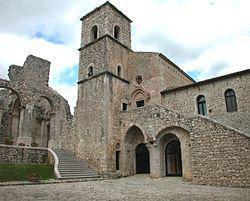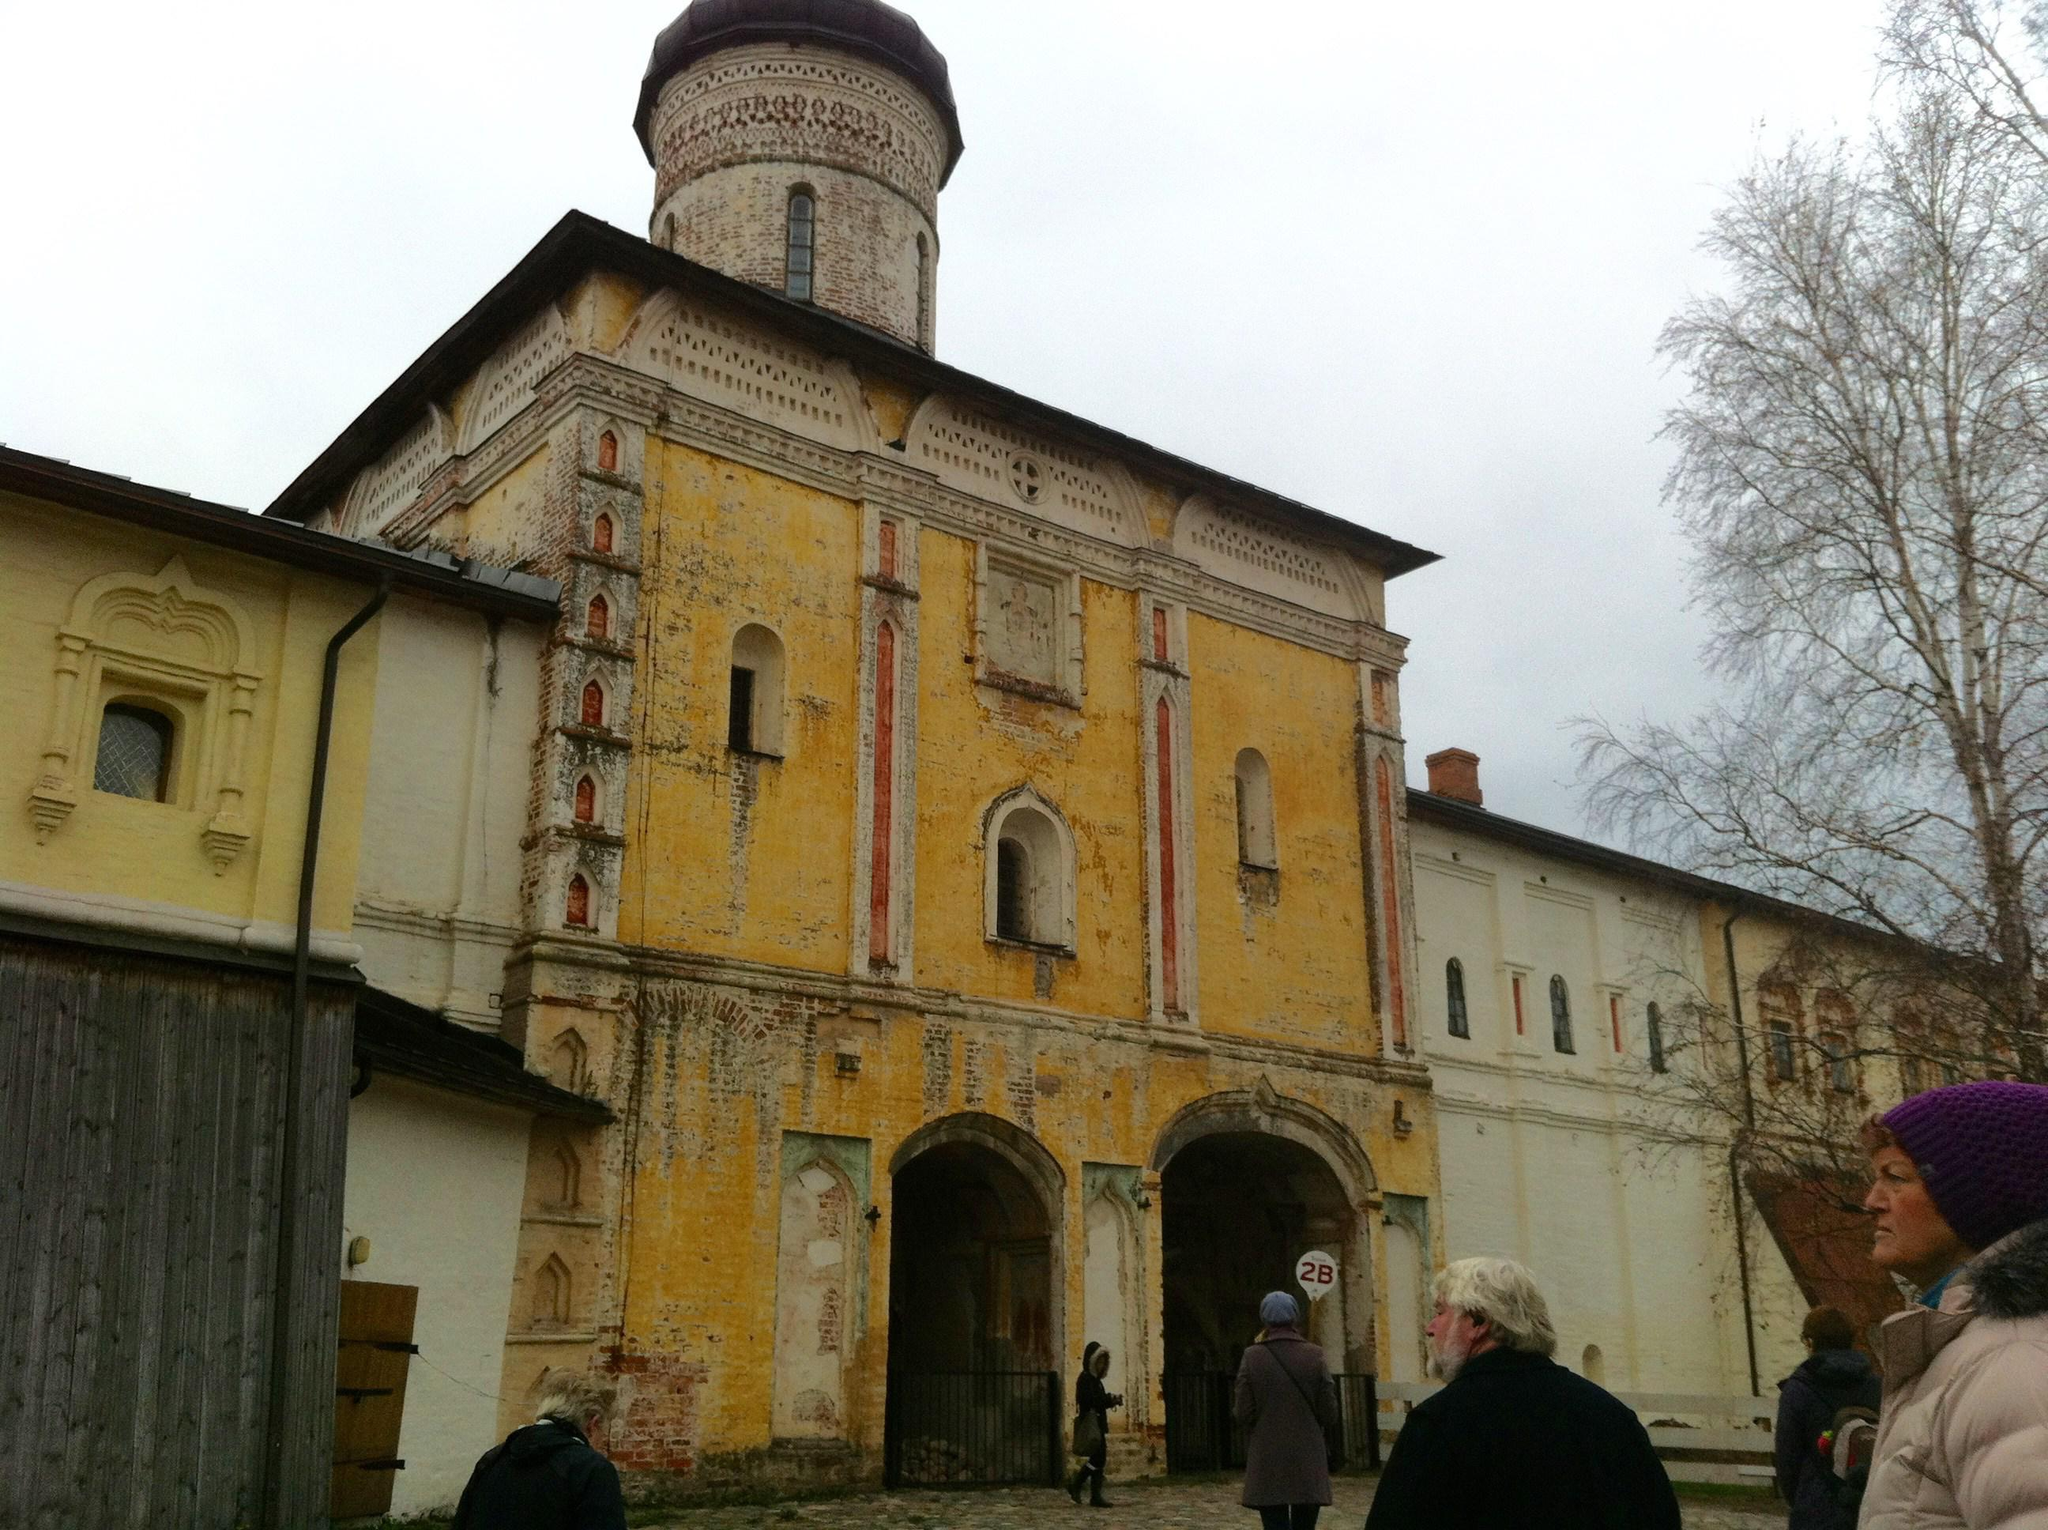The first image is the image on the left, the second image is the image on the right. For the images shown, is this caption "There are two steeples in the image on the right." true? Answer yes or no. No. The first image is the image on the left, the second image is the image on the right. For the images shown, is this caption "An image shows a building with a tall black-topped tower on top of a black peaked roof, in front of a vivid blue with only a tiny cloud patch visible." true? Answer yes or no. No. 